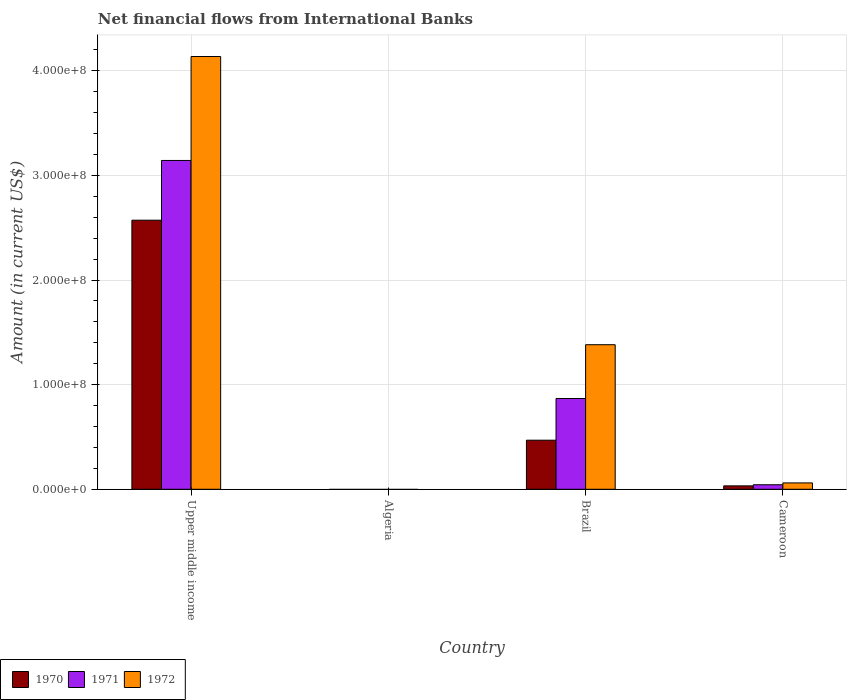How many bars are there on the 3rd tick from the right?
Give a very brief answer. 0. What is the label of the 1st group of bars from the left?
Your answer should be compact. Upper middle income. Across all countries, what is the maximum net financial aid flows in 1970?
Offer a very short reply. 2.57e+08. Across all countries, what is the minimum net financial aid flows in 1970?
Provide a succinct answer. 0. In which country was the net financial aid flows in 1971 maximum?
Provide a short and direct response. Upper middle income. What is the total net financial aid flows in 1970 in the graph?
Your answer should be very brief. 3.07e+08. What is the difference between the net financial aid flows in 1971 in Cameroon and that in Upper middle income?
Offer a terse response. -3.10e+08. What is the difference between the net financial aid flows in 1971 in Upper middle income and the net financial aid flows in 1972 in Brazil?
Make the answer very short. 1.76e+08. What is the average net financial aid flows in 1972 per country?
Ensure brevity in your answer.  1.39e+08. What is the difference between the net financial aid flows of/in 1971 and net financial aid flows of/in 1970 in Cameroon?
Keep it short and to the point. 1.07e+06. In how many countries, is the net financial aid flows in 1972 greater than 100000000 US$?
Give a very brief answer. 2. What is the ratio of the net financial aid flows in 1971 in Cameroon to that in Upper middle income?
Offer a terse response. 0.01. Is the difference between the net financial aid flows in 1971 in Cameroon and Upper middle income greater than the difference between the net financial aid flows in 1970 in Cameroon and Upper middle income?
Your answer should be compact. No. What is the difference between the highest and the second highest net financial aid flows in 1970?
Keep it short and to the point. 2.54e+08. What is the difference between the highest and the lowest net financial aid flows in 1972?
Your response must be concise. 4.14e+08. In how many countries, is the net financial aid flows in 1972 greater than the average net financial aid flows in 1972 taken over all countries?
Your response must be concise. 1. Is the sum of the net financial aid flows in 1972 in Brazil and Upper middle income greater than the maximum net financial aid flows in 1970 across all countries?
Offer a terse response. Yes. How many bars are there?
Provide a short and direct response. 9. Are all the bars in the graph horizontal?
Your answer should be very brief. No. Are the values on the major ticks of Y-axis written in scientific E-notation?
Provide a short and direct response. Yes. Does the graph contain any zero values?
Keep it short and to the point. Yes. How many legend labels are there?
Keep it short and to the point. 3. How are the legend labels stacked?
Provide a short and direct response. Horizontal. What is the title of the graph?
Your answer should be very brief. Net financial flows from International Banks. What is the label or title of the X-axis?
Make the answer very short. Country. What is the Amount (in current US$) of 1970 in Upper middle income?
Provide a short and direct response. 2.57e+08. What is the Amount (in current US$) of 1971 in Upper middle income?
Keep it short and to the point. 3.14e+08. What is the Amount (in current US$) in 1972 in Upper middle income?
Provide a succinct answer. 4.14e+08. What is the Amount (in current US$) of 1970 in Algeria?
Ensure brevity in your answer.  0. What is the Amount (in current US$) of 1971 in Algeria?
Offer a very short reply. 0. What is the Amount (in current US$) of 1972 in Algeria?
Offer a terse response. 0. What is the Amount (in current US$) in 1970 in Brazil?
Offer a terse response. 4.69e+07. What is the Amount (in current US$) in 1971 in Brazil?
Ensure brevity in your answer.  8.68e+07. What is the Amount (in current US$) in 1972 in Brazil?
Give a very brief answer. 1.38e+08. What is the Amount (in current US$) of 1970 in Cameroon?
Keep it short and to the point. 3.25e+06. What is the Amount (in current US$) of 1971 in Cameroon?
Provide a succinct answer. 4.32e+06. What is the Amount (in current US$) of 1972 in Cameroon?
Ensure brevity in your answer.  6.09e+06. Across all countries, what is the maximum Amount (in current US$) of 1970?
Your response must be concise. 2.57e+08. Across all countries, what is the maximum Amount (in current US$) of 1971?
Ensure brevity in your answer.  3.14e+08. Across all countries, what is the maximum Amount (in current US$) of 1972?
Make the answer very short. 4.14e+08. Across all countries, what is the minimum Amount (in current US$) in 1970?
Give a very brief answer. 0. Across all countries, what is the minimum Amount (in current US$) in 1971?
Your answer should be compact. 0. What is the total Amount (in current US$) of 1970 in the graph?
Your answer should be very brief. 3.07e+08. What is the total Amount (in current US$) of 1971 in the graph?
Provide a short and direct response. 4.05e+08. What is the total Amount (in current US$) of 1972 in the graph?
Offer a terse response. 5.58e+08. What is the difference between the Amount (in current US$) in 1970 in Upper middle income and that in Brazil?
Give a very brief answer. 2.10e+08. What is the difference between the Amount (in current US$) in 1971 in Upper middle income and that in Brazil?
Offer a very short reply. 2.28e+08. What is the difference between the Amount (in current US$) in 1972 in Upper middle income and that in Brazil?
Keep it short and to the point. 2.75e+08. What is the difference between the Amount (in current US$) of 1970 in Upper middle income and that in Cameroon?
Provide a succinct answer. 2.54e+08. What is the difference between the Amount (in current US$) of 1971 in Upper middle income and that in Cameroon?
Provide a succinct answer. 3.10e+08. What is the difference between the Amount (in current US$) in 1972 in Upper middle income and that in Cameroon?
Offer a very short reply. 4.08e+08. What is the difference between the Amount (in current US$) in 1970 in Brazil and that in Cameroon?
Ensure brevity in your answer.  4.37e+07. What is the difference between the Amount (in current US$) in 1971 in Brazil and that in Cameroon?
Offer a very short reply. 8.25e+07. What is the difference between the Amount (in current US$) of 1972 in Brazil and that in Cameroon?
Give a very brief answer. 1.32e+08. What is the difference between the Amount (in current US$) in 1970 in Upper middle income and the Amount (in current US$) in 1971 in Brazil?
Provide a succinct answer. 1.70e+08. What is the difference between the Amount (in current US$) in 1970 in Upper middle income and the Amount (in current US$) in 1972 in Brazil?
Give a very brief answer. 1.19e+08. What is the difference between the Amount (in current US$) of 1971 in Upper middle income and the Amount (in current US$) of 1972 in Brazil?
Your answer should be very brief. 1.76e+08. What is the difference between the Amount (in current US$) in 1970 in Upper middle income and the Amount (in current US$) in 1971 in Cameroon?
Ensure brevity in your answer.  2.53e+08. What is the difference between the Amount (in current US$) in 1970 in Upper middle income and the Amount (in current US$) in 1972 in Cameroon?
Give a very brief answer. 2.51e+08. What is the difference between the Amount (in current US$) in 1971 in Upper middle income and the Amount (in current US$) in 1972 in Cameroon?
Ensure brevity in your answer.  3.08e+08. What is the difference between the Amount (in current US$) of 1970 in Brazil and the Amount (in current US$) of 1971 in Cameroon?
Provide a succinct answer. 4.26e+07. What is the difference between the Amount (in current US$) of 1970 in Brazil and the Amount (in current US$) of 1972 in Cameroon?
Ensure brevity in your answer.  4.08e+07. What is the difference between the Amount (in current US$) in 1971 in Brazil and the Amount (in current US$) in 1972 in Cameroon?
Your answer should be compact. 8.07e+07. What is the average Amount (in current US$) in 1970 per country?
Your answer should be compact. 7.68e+07. What is the average Amount (in current US$) of 1971 per country?
Ensure brevity in your answer.  1.01e+08. What is the average Amount (in current US$) in 1972 per country?
Provide a short and direct response. 1.39e+08. What is the difference between the Amount (in current US$) in 1970 and Amount (in current US$) in 1971 in Upper middle income?
Give a very brief answer. -5.71e+07. What is the difference between the Amount (in current US$) in 1970 and Amount (in current US$) in 1972 in Upper middle income?
Provide a short and direct response. -1.56e+08. What is the difference between the Amount (in current US$) of 1971 and Amount (in current US$) of 1972 in Upper middle income?
Ensure brevity in your answer.  -9.94e+07. What is the difference between the Amount (in current US$) in 1970 and Amount (in current US$) in 1971 in Brazil?
Offer a very short reply. -3.99e+07. What is the difference between the Amount (in current US$) in 1970 and Amount (in current US$) in 1972 in Brazil?
Offer a terse response. -9.13e+07. What is the difference between the Amount (in current US$) in 1971 and Amount (in current US$) in 1972 in Brazil?
Ensure brevity in your answer.  -5.14e+07. What is the difference between the Amount (in current US$) of 1970 and Amount (in current US$) of 1971 in Cameroon?
Your answer should be compact. -1.07e+06. What is the difference between the Amount (in current US$) of 1970 and Amount (in current US$) of 1972 in Cameroon?
Your answer should be compact. -2.84e+06. What is the difference between the Amount (in current US$) in 1971 and Amount (in current US$) in 1972 in Cameroon?
Give a very brief answer. -1.77e+06. What is the ratio of the Amount (in current US$) of 1970 in Upper middle income to that in Brazil?
Your answer should be very brief. 5.48. What is the ratio of the Amount (in current US$) of 1971 in Upper middle income to that in Brazil?
Give a very brief answer. 3.62. What is the ratio of the Amount (in current US$) in 1972 in Upper middle income to that in Brazil?
Make the answer very short. 2.99. What is the ratio of the Amount (in current US$) in 1970 in Upper middle income to that in Cameroon?
Keep it short and to the point. 79.15. What is the ratio of the Amount (in current US$) in 1971 in Upper middle income to that in Cameroon?
Your answer should be very brief. 72.81. What is the ratio of the Amount (in current US$) in 1972 in Upper middle income to that in Cameroon?
Offer a terse response. 67.96. What is the ratio of the Amount (in current US$) of 1970 in Brazil to that in Cameroon?
Ensure brevity in your answer.  14.44. What is the ratio of the Amount (in current US$) of 1971 in Brazil to that in Cameroon?
Your answer should be very brief. 20.1. What is the ratio of the Amount (in current US$) of 1972 in Brazil to that in Cameroon?
Provide a succinct answer. 22.7. What is the difference between the highest and the second highest Amount (in current US$) in 1970?
Your answer should be compact. 2.10e+08. What is the difference between the highest and the second highest Amount (in current US$) of 1971?
Your answer should be compact. 2.28e+08. What is the difference between the highest and the second highest Amount (in current US$) in 1972?
Your answer should be compact. 2.75e+08. What is the difference between the highest and the lowest Amount (in current US$) in 1970?
Your answer should be very brief. 2.57e+08. What is the difference between the highest and the lowest Amount (in current US$) in 1971?
Give a very brief answer. 3.14e+08. What is the difference between the highest and the lowest Amount (in current US$) of 1972?
Provide a succinct answer. 4.14e+08. 